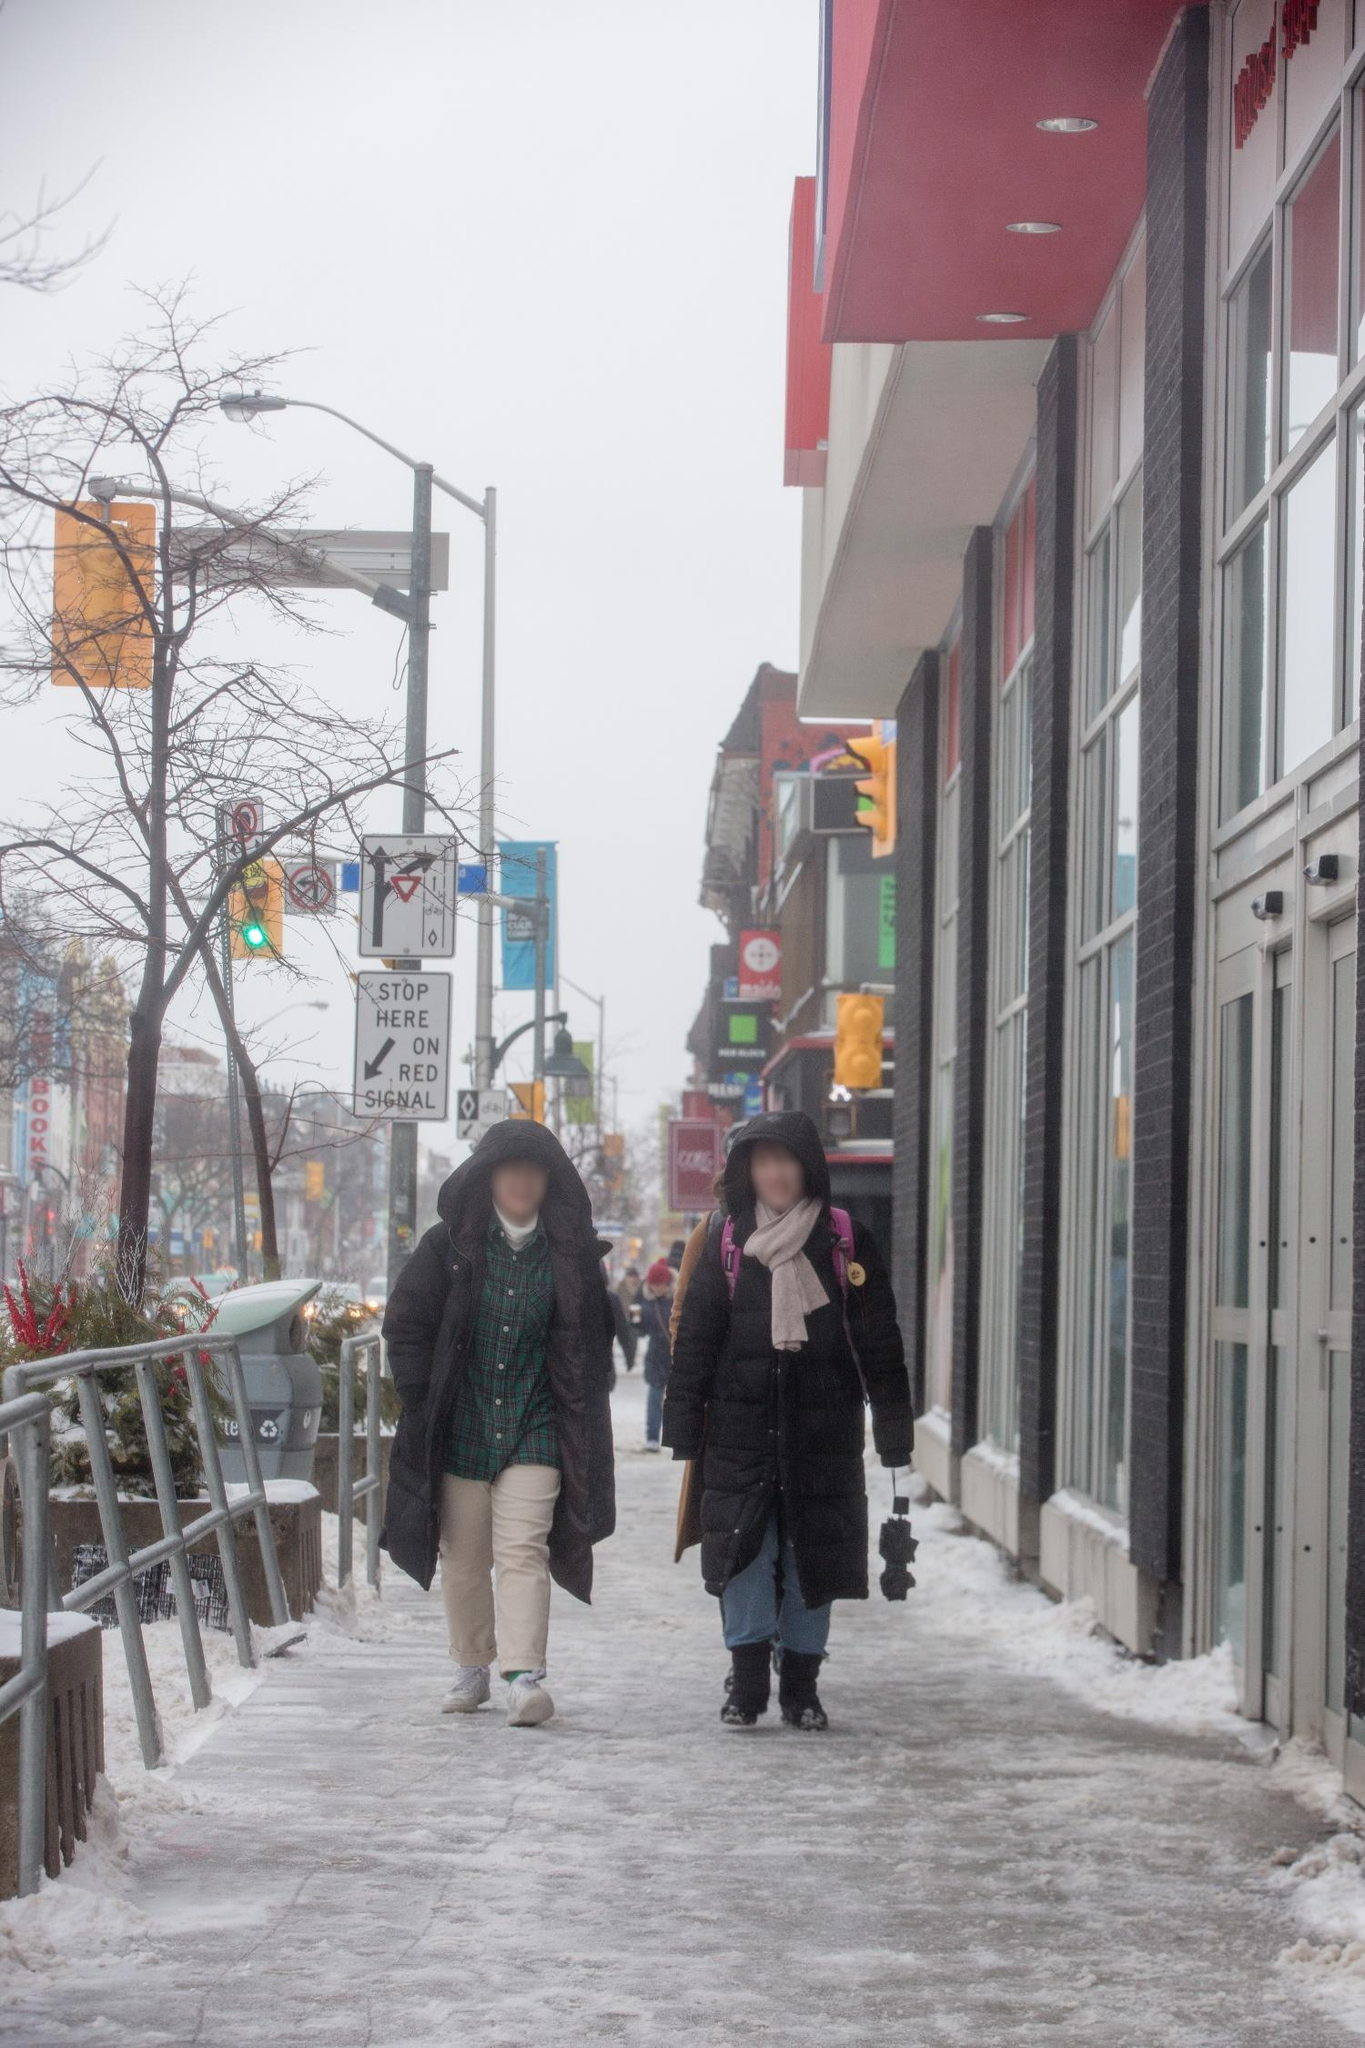It looks quite snowy and cold. Can you describe the atmosphere and feeling of this place for me? The atmosphere in this image speaks to the quintessential quiet that comes with a snowy day in the city. The sky is a uniform gray, casting a muted light over the scene. The snow on the sidewalk crunches underfoot as two bundled figures walk side by side, their breath visible in the cold air. The vibrant red of the building catches the eye, creating a warm contrast to the chilly surroundings. The sparse traffic and distant street signs suggest a city that’s slowed down by the weather, adding to the serene yet bustling urban charm. Can you imagine a story for the two individuals walking together? Certainly! Let's imagine these two individuals are lifelong friends who haven't seen each other in years. Spontaneously meeting in their hometown, they decided to take a nostalgic walk through the city streets they once knew so well. As they tread carefully on the icy path, laughter echoes between them as they reminisce about old times and share new stories. The person in the green coat, let's call them Alex, tells tales of adventures abroad, while the companion in the black coat, maybe sharegpt4v/sam, shares sweet memories of family and local changes. Their shared warmth and camaraderie seem to melt away the winter's chill, making this walk a treasured moment in their rekindled friendship. 